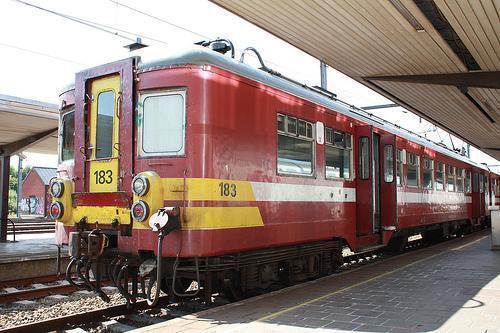How many numbers are on the train?
Give a very brief answer. 6. 